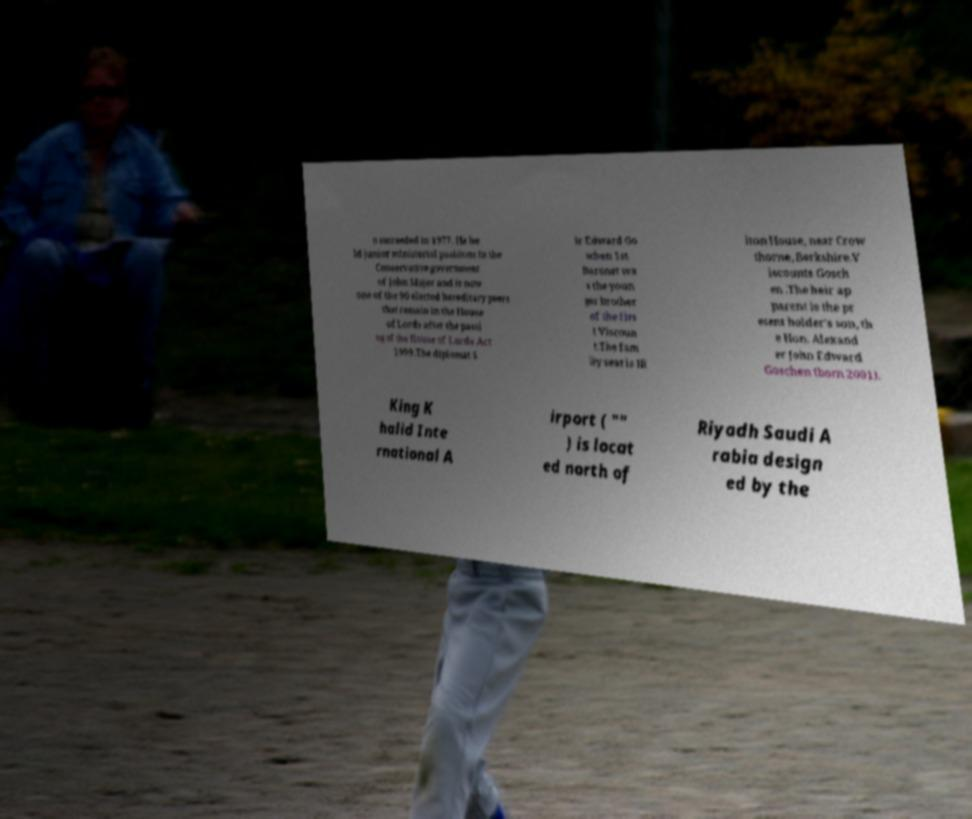Can you read and provide the text displayed in the image?This photo seems to have some interesting text. Can you extract and type it out for me? o succeeded in 1977. He he ld junior ministerial positions in the Conservative government of John Major and is now one of the 90 elected hereditary peers that remain in the House of Lords after the passi ng of the House of Lords Act 1999.The diplomat S ir Edward Go schen 1st Baronet wa s the youn ger brother of the firs t Viscoun t.The fam ily seat is Hi lton House, near Crow thorne, Berkshire.V iscounts Gosch en .The heir ap parent is the pr esent holder's son, th e Hon. Alexand er John Edward Goschen (born 2001). King K halid Inte rnational A irport ( "" ) is locat ed north of Riyadh Saudi A rabia design ed by the 